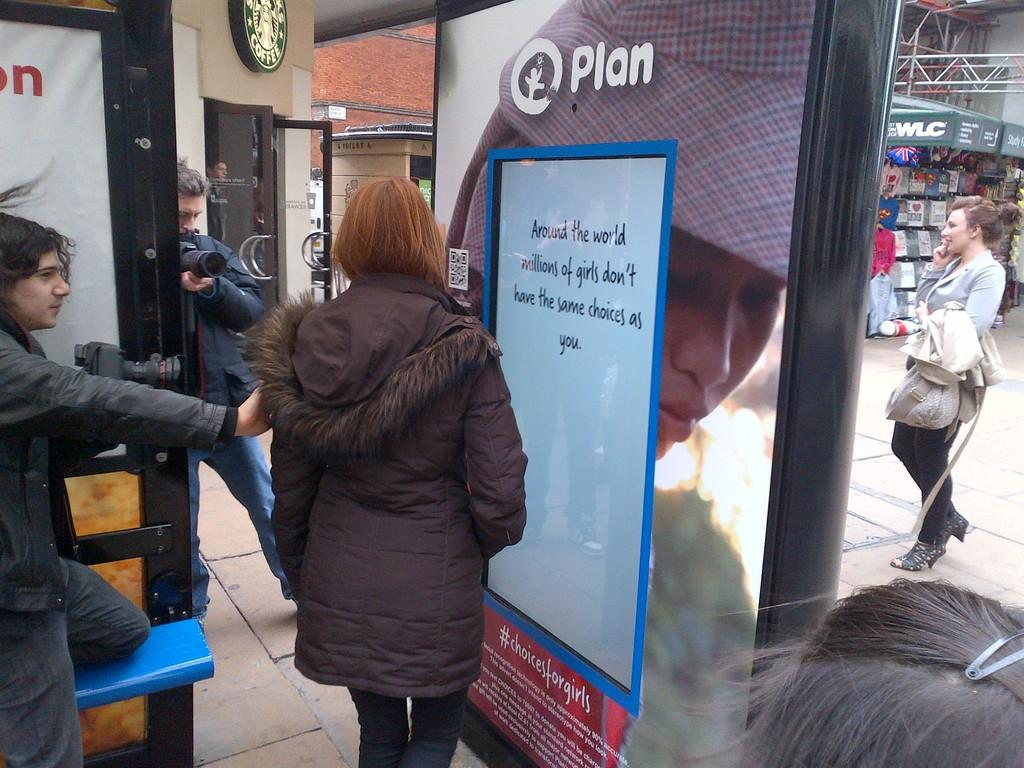What is happening on the road in the image? There is a group of people on the road in the image. What can be seen in addition to the people on the road? Boards, a wall, metal rods, and shops are visible in the image. Can you describe the time of day when the image was taken? The image was taken during the day. How many goldfish are swimming in the water near the shops in the image? There are no goldfish present in the image; it features a group of people on the road, boards, a wall, metal rods, and shops. What type of hook is being used by the people in the image? There is no hook visible in the image; it features a group of people on the road, boards, a wall, metal rods, and shops. 